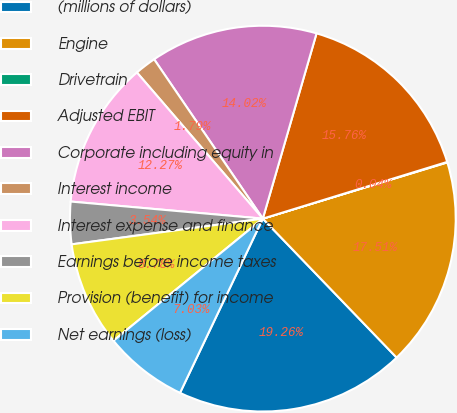<chart> <loc_0><loc_0><loc_500><loc_500><pie_chart><fcel>(millions of dollars)<fcel>Engine<fcel>Drivetrain<fcel>Adjusted EBIT<fcel>Corporate including equity in<fcel>Interest income<fcel>Interest expense and finance<fcel>Earnings before income taxes<fcel>Provision (benefit) for income<fcel>Net earnings (loss)<nl><fcel>19.26%<fcel>17.51%<fcel>0.04%<fcel>15.76%<fcel>14.02%<fcel>1.79%<fcel>12.27%<fcel>3.54%<fcel>8.78%<fcel>7.03%<nl></chart> 